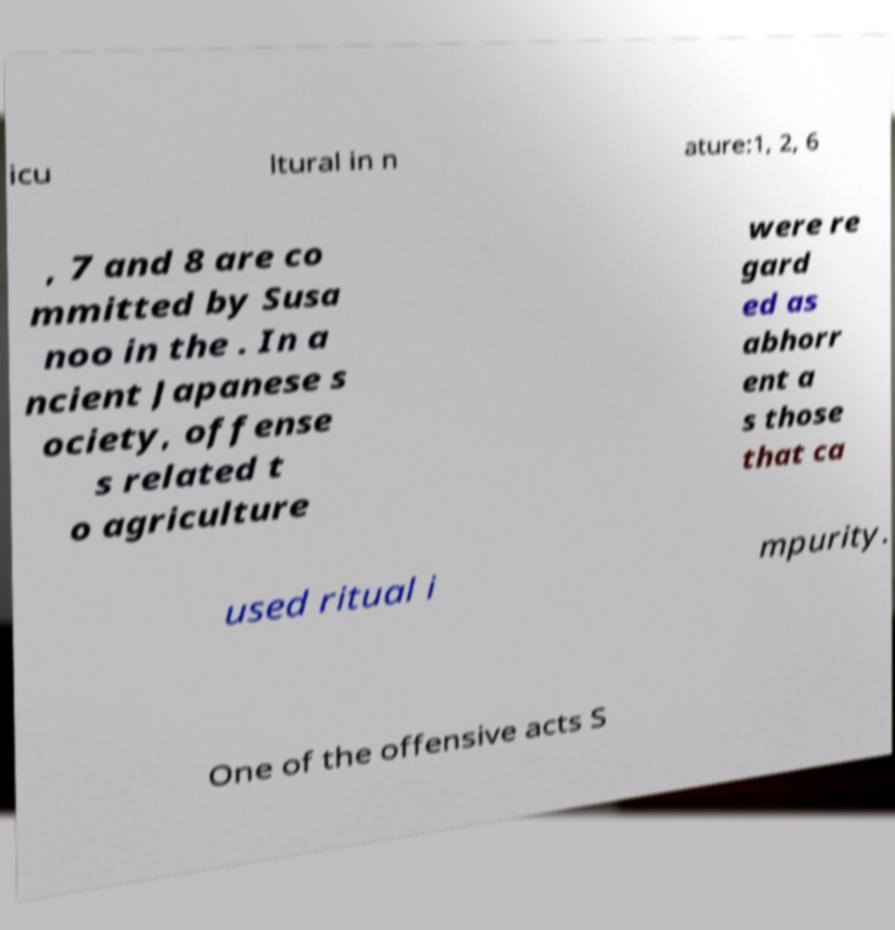Could you extract and type out the text from this image? icu ltural in n ature:1, 2, 6 , 7 and 8 are co mmitted by Susa noo in the . In a ncient Japanese s ociety, offense s related t o agriculture were re gard ed as abhorr ent a s those that ca used ritual i mpurity. One of the offensive acts S 